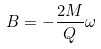Convert formula to latex. <formula><loc_0><loc_0><loc_500><loc_500>B = - \frac { 2 M } { Q } \omega</formula> 